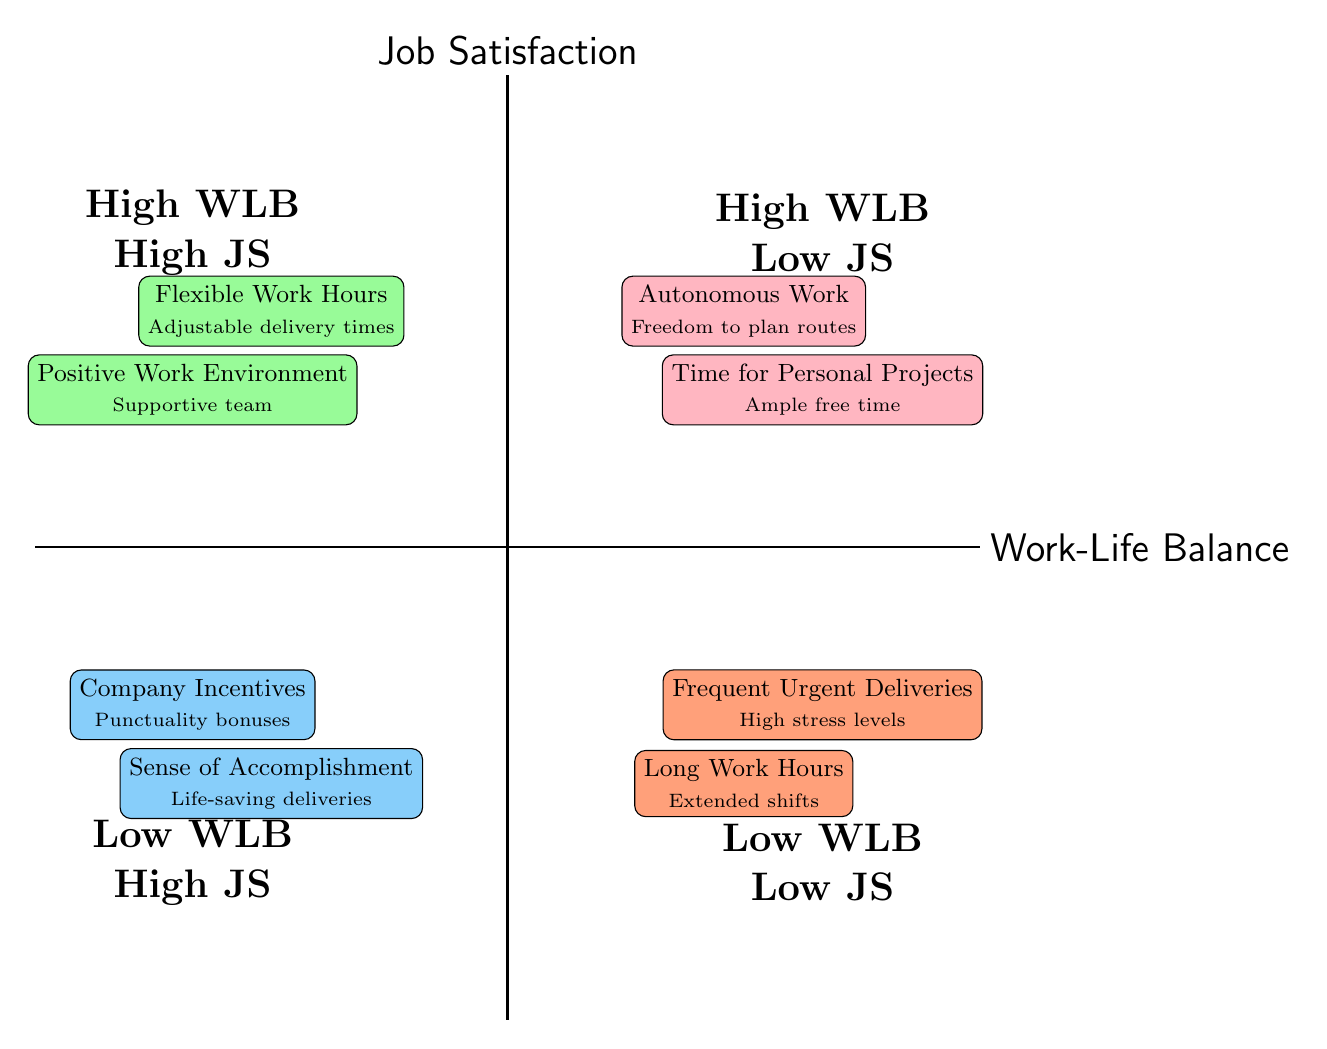What's located in the High Work-Life Balance and High Job Satisfaction quadrant? The elements in this quadrant are "Flexible Work Hours" and "Positive Work Environment." They are located near the top left side of the diagram.
Answer: Flexible Work Hours, Positive Work Environment How many elements are listed in the Low Work-Life Balance and Low Job Satisfaction quadrant? This quadrant contains two elements, which are "Long Work Hours" and "Frequent Urgent Deliveries," confirming that there are exactly two pieces of information represented here.
Answer: 2 What describes the High Work-Life Balance and Low Job Satisfaction quadrant? This quadrant represents situations where individuals can manage personal time well but do not feel recognized or satisfied with their job. The elements present are "Autonomous Work" and "Time for Personal Projects."
Answer: Autonomous Work, Time for Personal Projects In which quadrant would you find the element "Sense of Accomplishment"? The element "Sense of Accomplishment" is placed in the Low Work-Life Balance and High Job Satisfaction quadrant. This quadrant shows the scenario where job satisfaction is high despite work-life balance being low.
Answer: Low Work-Life Balance, High Job Satisfaction Which quadrant has elements that refer to stress? The Low Work-Life Balance and Low Job Satisfaction quadrant addresses stress through the elements "Long Work Hours" and "Frequent Urgent Deliveries". Both are linked to high stress levels from demanding work conditions.
Answer: Low Work-Life Balance, Low Job Satisfaction 